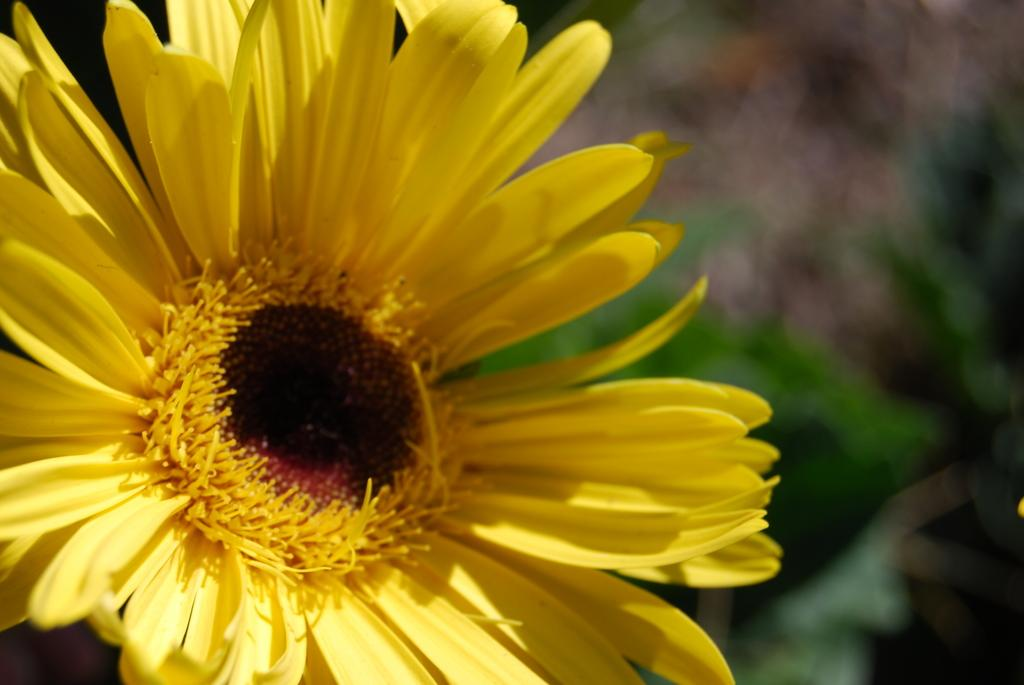What type of plant is featured in the image? There is a sunflower in the picture. Can you describe the background of the image? The background of the image is blurred. What type of game is being played in the background of the image? There is no game being played in the image; the background is blurred and does not show any specific activity or object. 